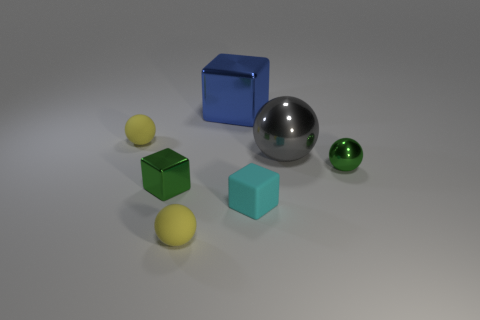Subtract all blue balls. Subtract all red cylinders. How many balls are left? 4 Add 2 big gray cylinders. How many objects exist? 9 Subtract all cubes. How many objects are left? 4 Subtract 0 cyan cylinders. How many objects are left? 7 Subtract all cyan matte cylinders. Subtract all green cubes. How many objects are left? 6 Add 2 rubber balls. How many rubber balls are left? 4 Add 6 cubes. How many cubes exist? 9 